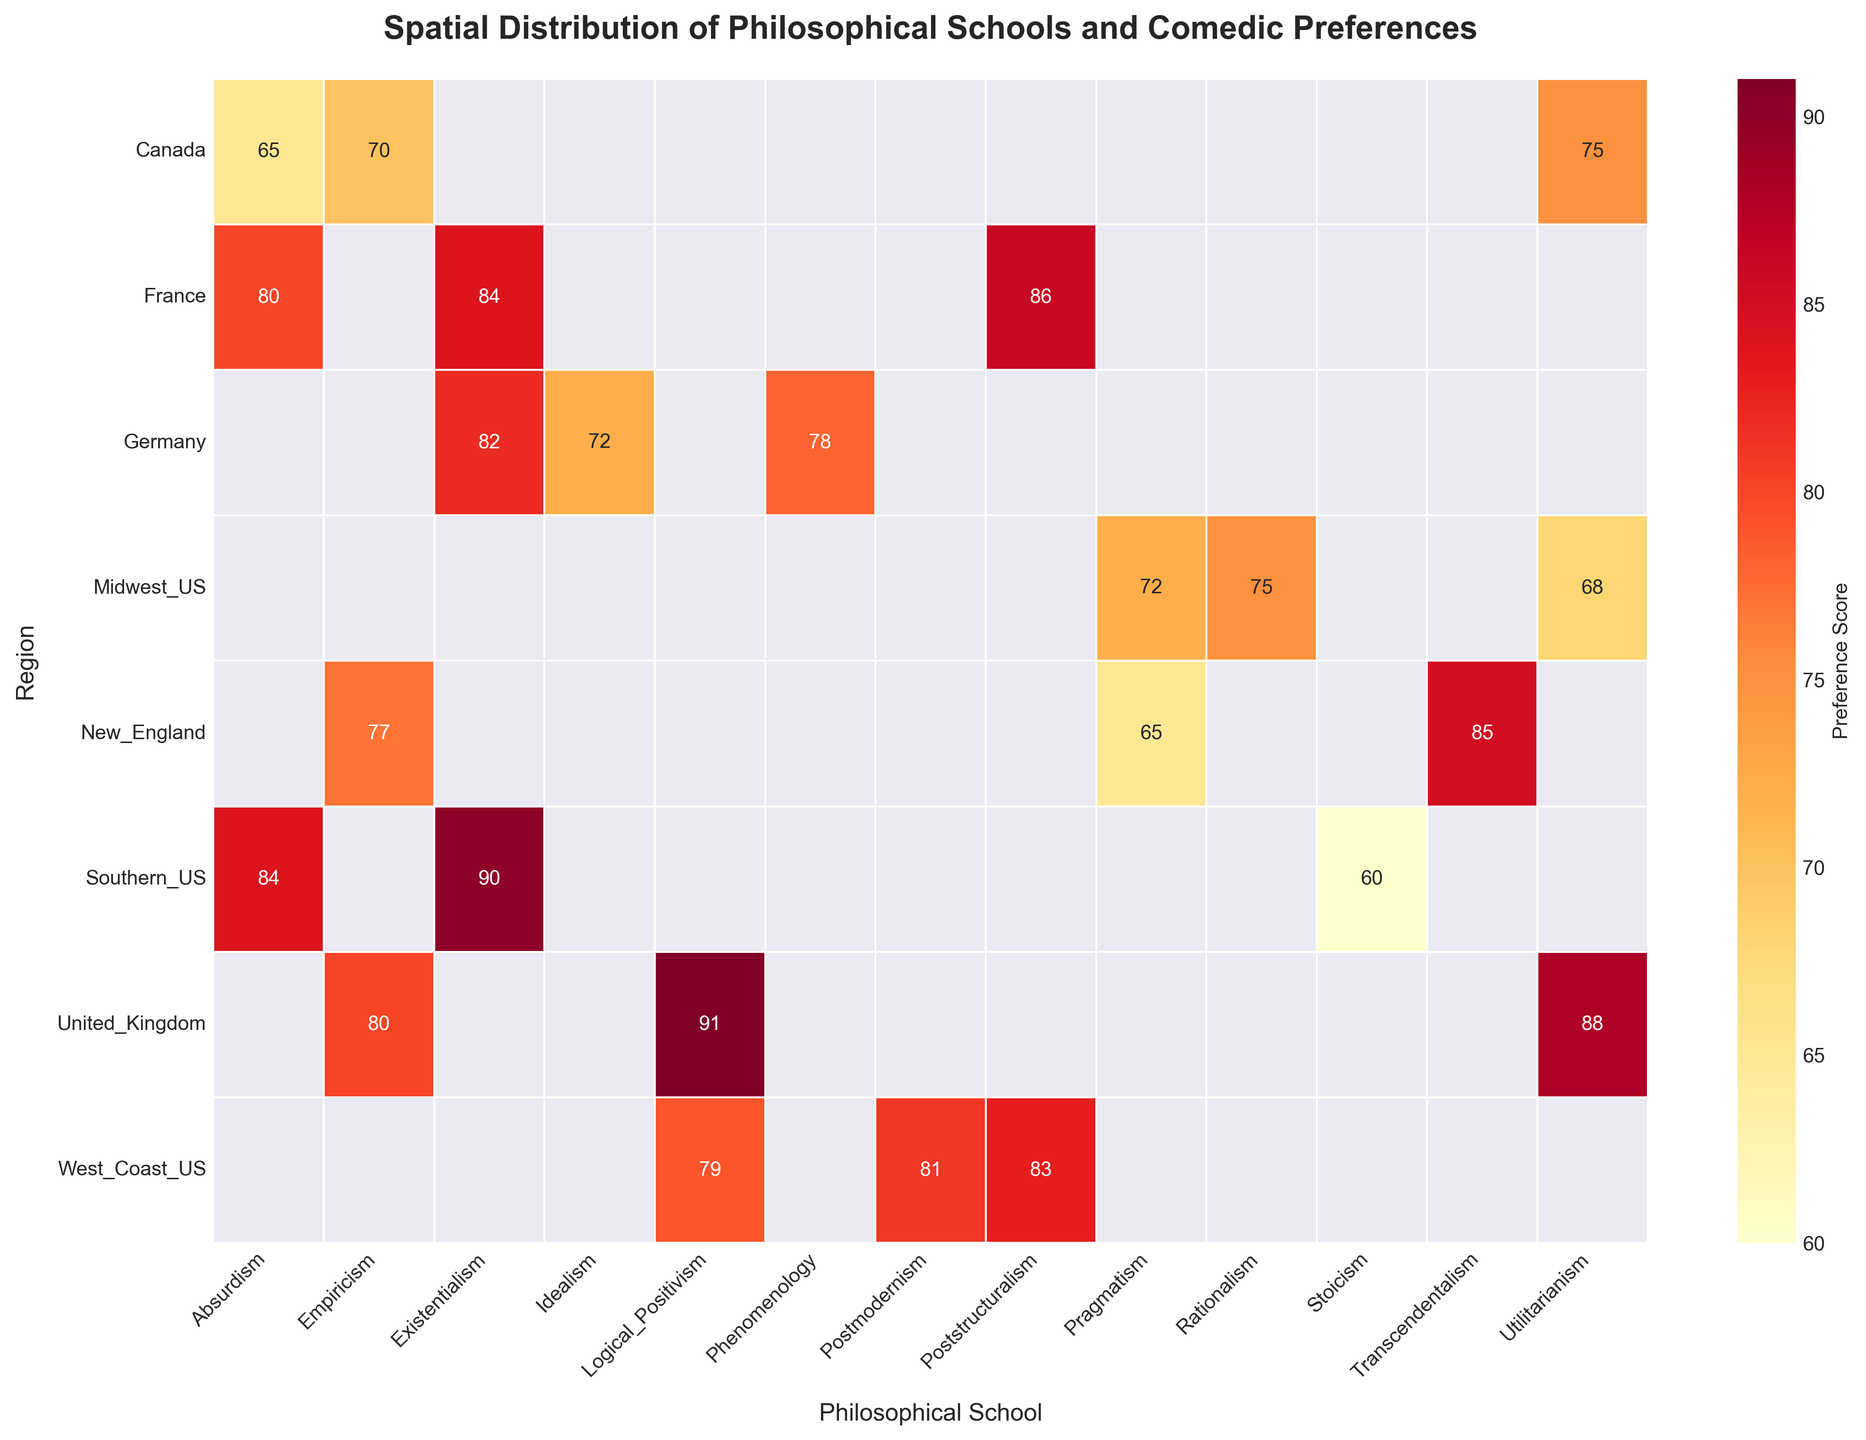What is the title of the heatmap? The title is displayed at the top of the heatmap in a larger, bold font which provides an overview of the dataset being visualized.
Answer: Spatial Distribution of Philosophical Schools and Comedic Preferences Which region shows the highest preference score for Existentialism? Find the row corresponding to Existentialism and identify the cell with the highest value within that row.
Answer: Southern_US What is the average preference score for the West_Coast_US region? Find the row for West_Coast_US and sum the scores (81 + 79 + 83), then divide by the number of philosophical schools (3).
Answer: 81 Compare the preference score for Surreal Humor in Southern_US and France. Which region has a higher score? Locate the cells for Surreal Humor in both Southern_US and France. Southern_US has a score of 84, while France has 86.
Answer: France Which philosophical school in the United_Kingdom shows the lowest preference score and what is the score? Identify the row for the United_Kingdom and find the cell with the lowest value. The scores are: 88 for Utilitarianism, 91 for Logical Positivism, and 80 for Empiricism, so Empiricism is the lowest.
Answer: Empiricism, 80 How many regions show a preference score above 80 for any philosophical school? Look at all regions and count how many regions have at least one score above 80. The regions are New_England, Southern_US, Midwest_US, West_Coast_US, United_Kingdom, Germany, and France.
Answer: 7 Which region prefers Absurdism the most and what is their score? Locate the row for Absurdism and identify the highest score. The scores are 84 for Southern_US, 65 for Canada, and 80 for France.
Answer: Southern_US, 84 What is the difference in preference scores for Empiricism between New_England and United_Kingdom? Find the scores for Empiricism in both New_England and United_Kingdom. The scores are 77 for New_England and 80 for United_Kingdom. The difference is 80 - 77.
Answer: 3 